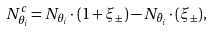<formula> <loc_0><loc_0><loc_500><loc_500>N ^ { c } _ { \theta _ { i } } = N _ { \theta _ { i } } \cdot ( 1 + \xi _ { \pm } ) - N _ { \bar { \theta _ { i } } } \cdot ( \xi _ { \pm } ) ,</formula> 